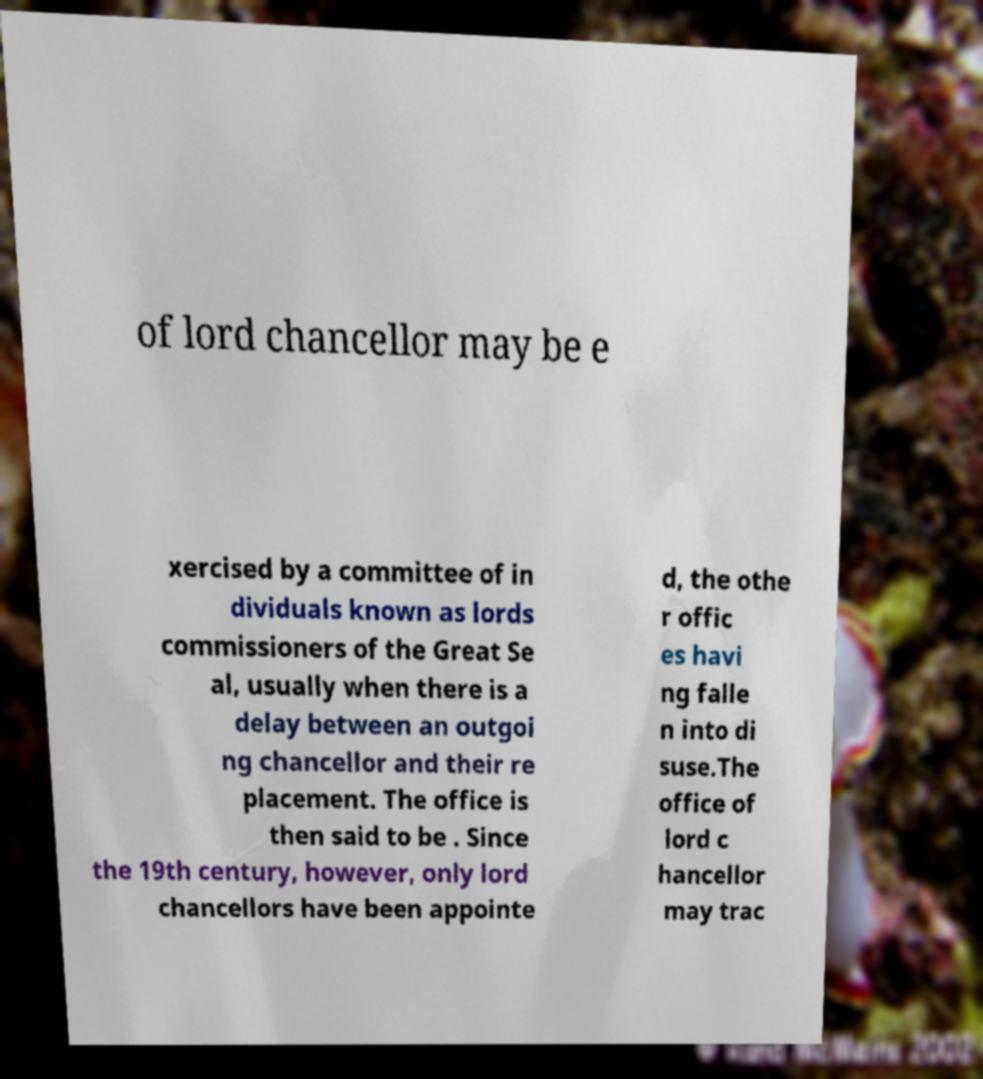Please identify and transcribe the text found in this image. of lord chancellor may be e xercised by a committee of in dividuals known as lords commissioners of the Great Se al, usually when there is a delay between an outgoi ng chancellor and their re placement. The office is then said to be . Since the 19th century, however, only lord chancellors have been appointe d, the othe r offic es havi ng falle n into di suse.The office of lord c hancellor may trac 